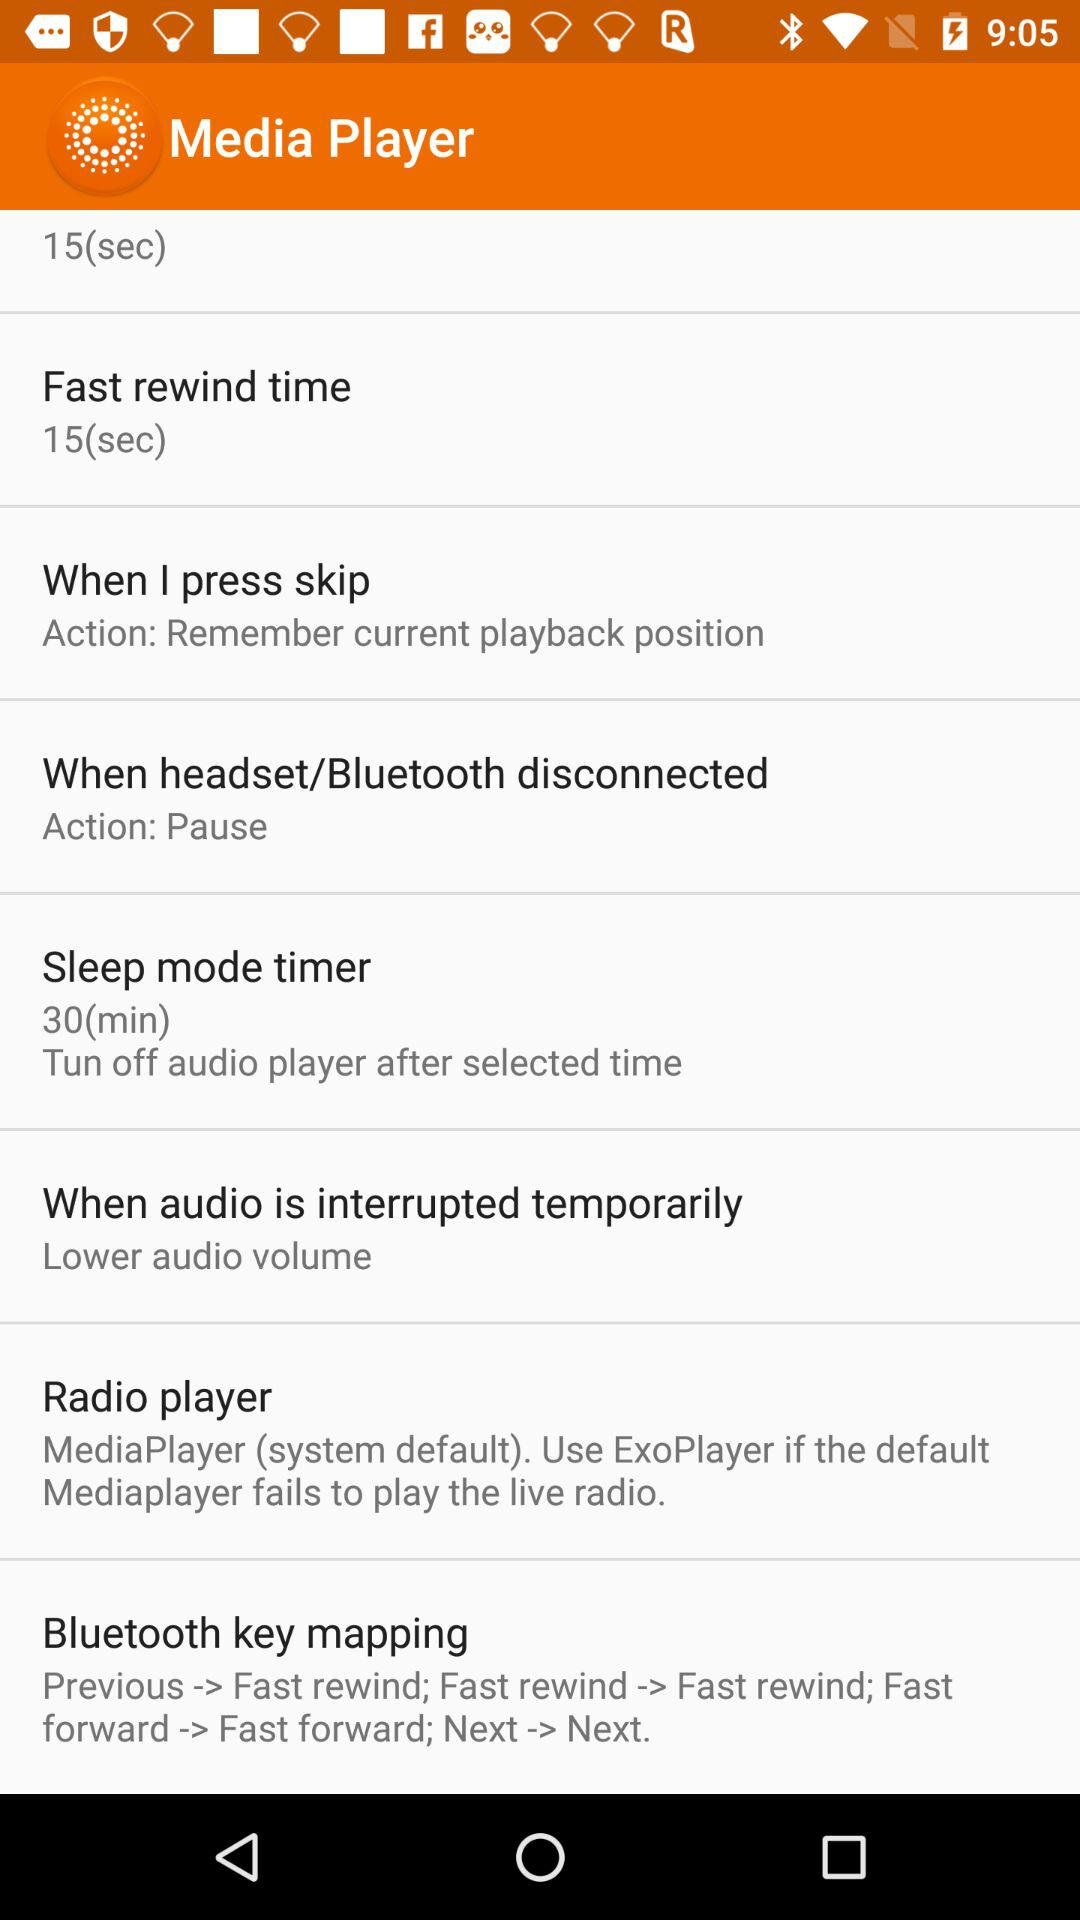How many songs are in the playlist?
When the provided information is insufficient, respond with <no answer>. <no answer> 